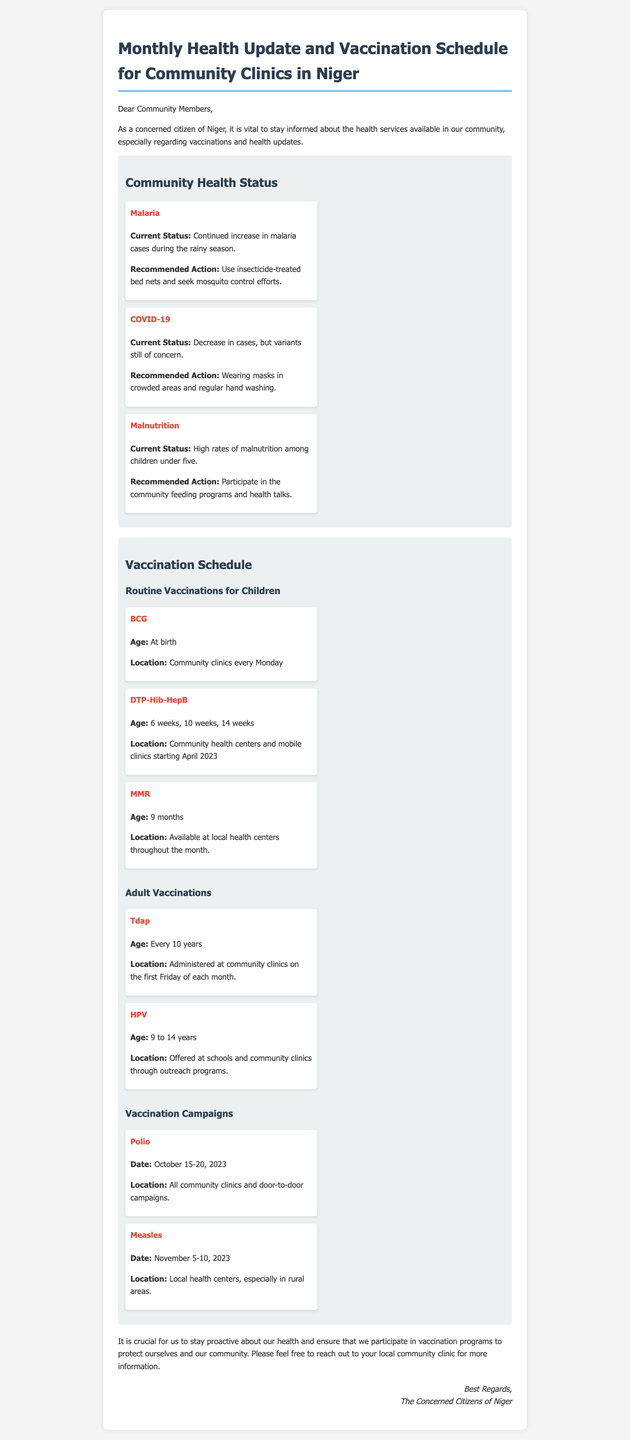What is the current status of malaria? The current status of malaria is discussed in the health status section, where it mentions a continued increase in malaria cases during the rainy season.
Answer: Continued increase What vaccinations are scheduled for children at birth? The document lists BCG as the vaccination given at birth under the vaccination schedule for children.
Answer: BCG When is the next Tdap vaccination scheduled? The document states Tdap vaccinations are administered at community clinics on the first Friday of each month.
Answer: First Friday of each month What is the date for the Polio vaccination campaign? The document specifies that the Polio vaccination campaign is set for October 15-20, 2023.
Answer: October 15-20, 2023 What is the recommended action for COVID-19? The health update suggests wearing masks in crowded areas and regular hand washing as the recommended action for COVID-19.
Answer: Wearing masks in crowded areas and regular hand washing How often should adults receive the Tdap vaccine? The document indicates that adults should receive the Tdap vaccine every 10 years.
Answer: Every 10 years What proportion of malnutrition is reported among children under five? The health status mentions high rates of malnutrition among children under five but does not provide an exact percentage.
Answer: High rates Where can BCG vaccinations be received? The vaccination schedule specifies that BCG vaccinations are available at community clinics every Monday.
Answer: Community clinics every Monday What community health program helps with malnutrition? The document recommends participation in community feeding programs and health talks to address malnutrition.
Answer: Community feeding programs and health talks 